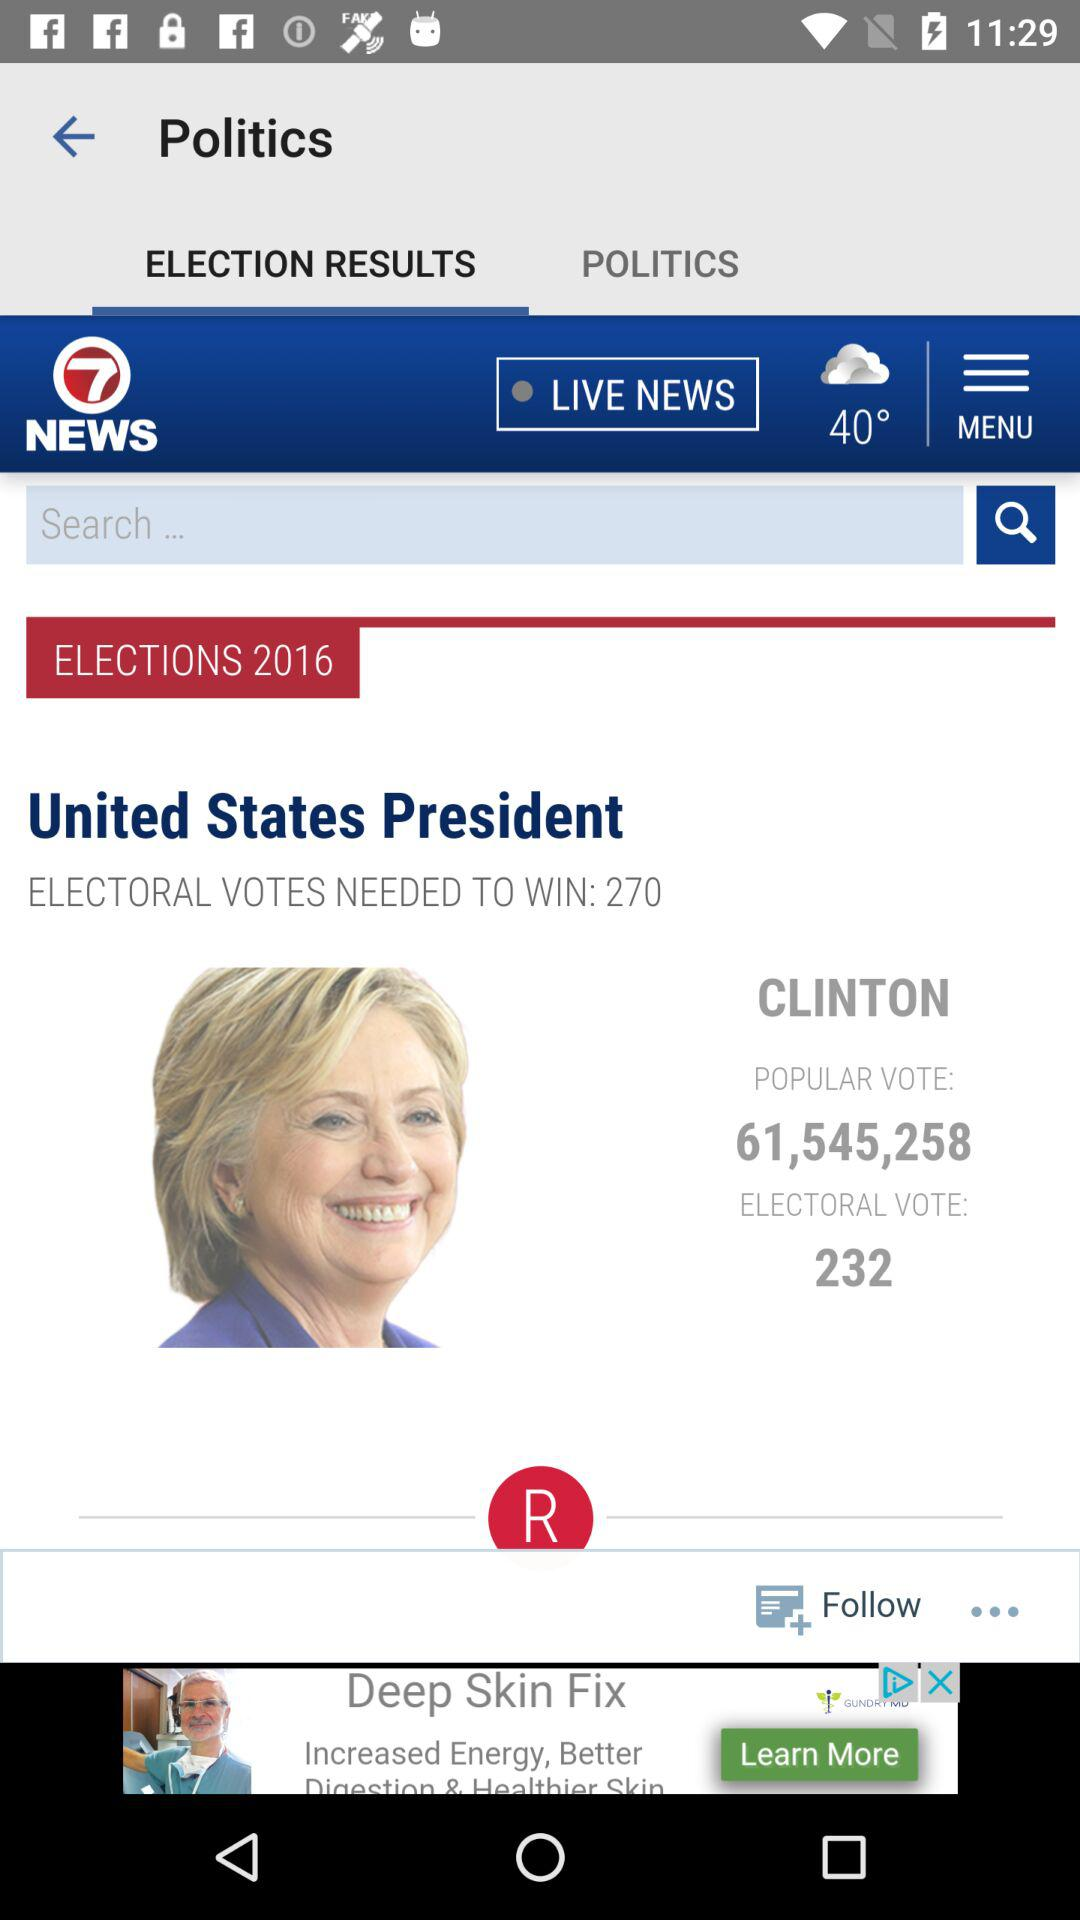What is the election year? The election year is 2016. 